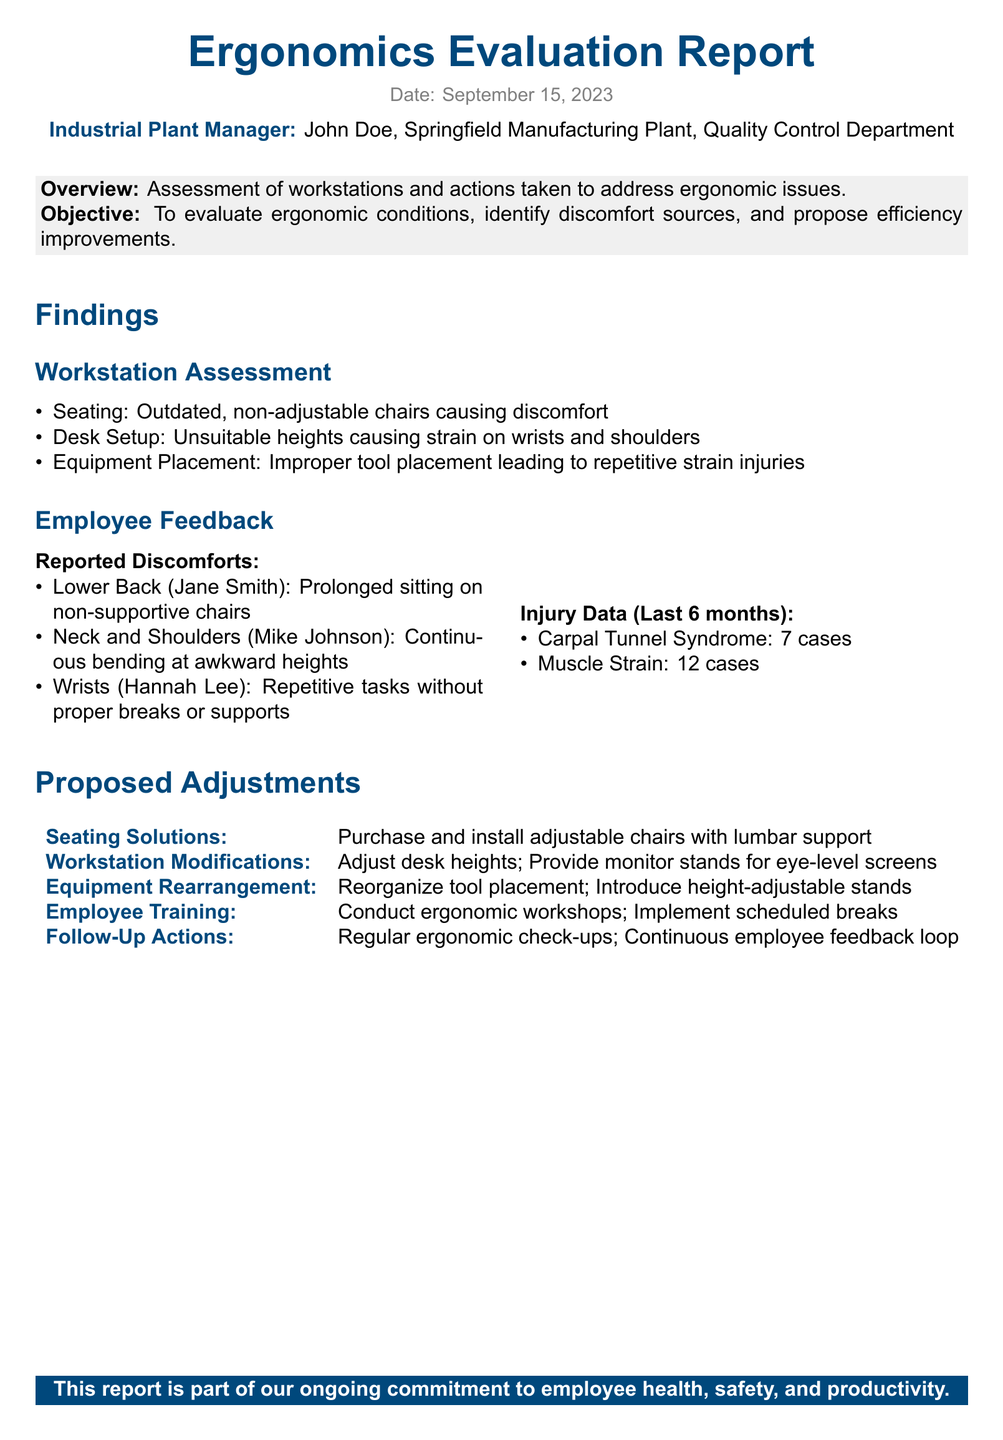What is the date of the report? The date is explicitly mentioned at the beginning of the report.
Answer: September 15, 2023 Who is the industrial plant manager? The name of the manager is stated in the report.
Answer: John Doe How many cases of Carpal Tunnel Syndrome were reported? The report lists the specific number of cases in the injury data section.
Answer: 7 cases What ergonomic issue is related to Jane Smith? The report highlights specific discomforts reported by employees.
Answer: Lower Back What adjustments are proposed for seating solutions? The report lists the actions to be taken for improving seating conditions.
Answer: Adjustable chairs with lumbar support 